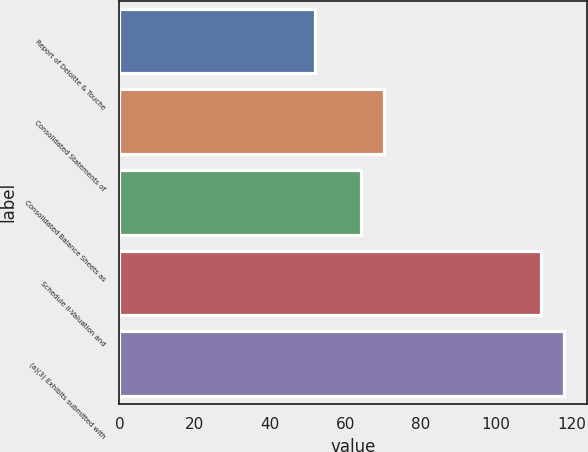Convert chart. <chart><loc_0><loc_0><loc_500><loc_500><bar_chart><fcel>Report of Deloitte & Touche<fcel>Consolidated Statements of<fcel>Consolidated Balance Sheets as<fcel>Schedule II-Valuation and<fcel>(a)(3) Exhibits submitted with<nl><fcel>52<fcel>70.3<fcel>64.2<fcel>112<fcel>118.1<nl></chart> 